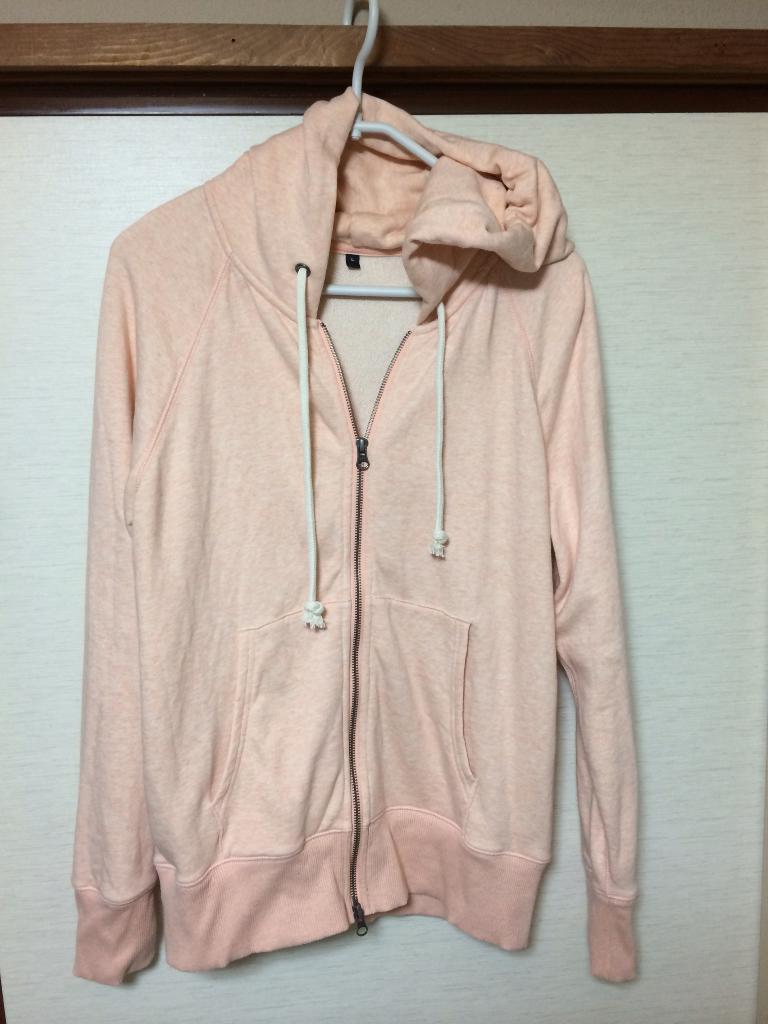How would you summarize this image in a sentence or two? In the image we can see a sweater, hanged to the hanged and the background is white in color. This is a wooden sheet. 